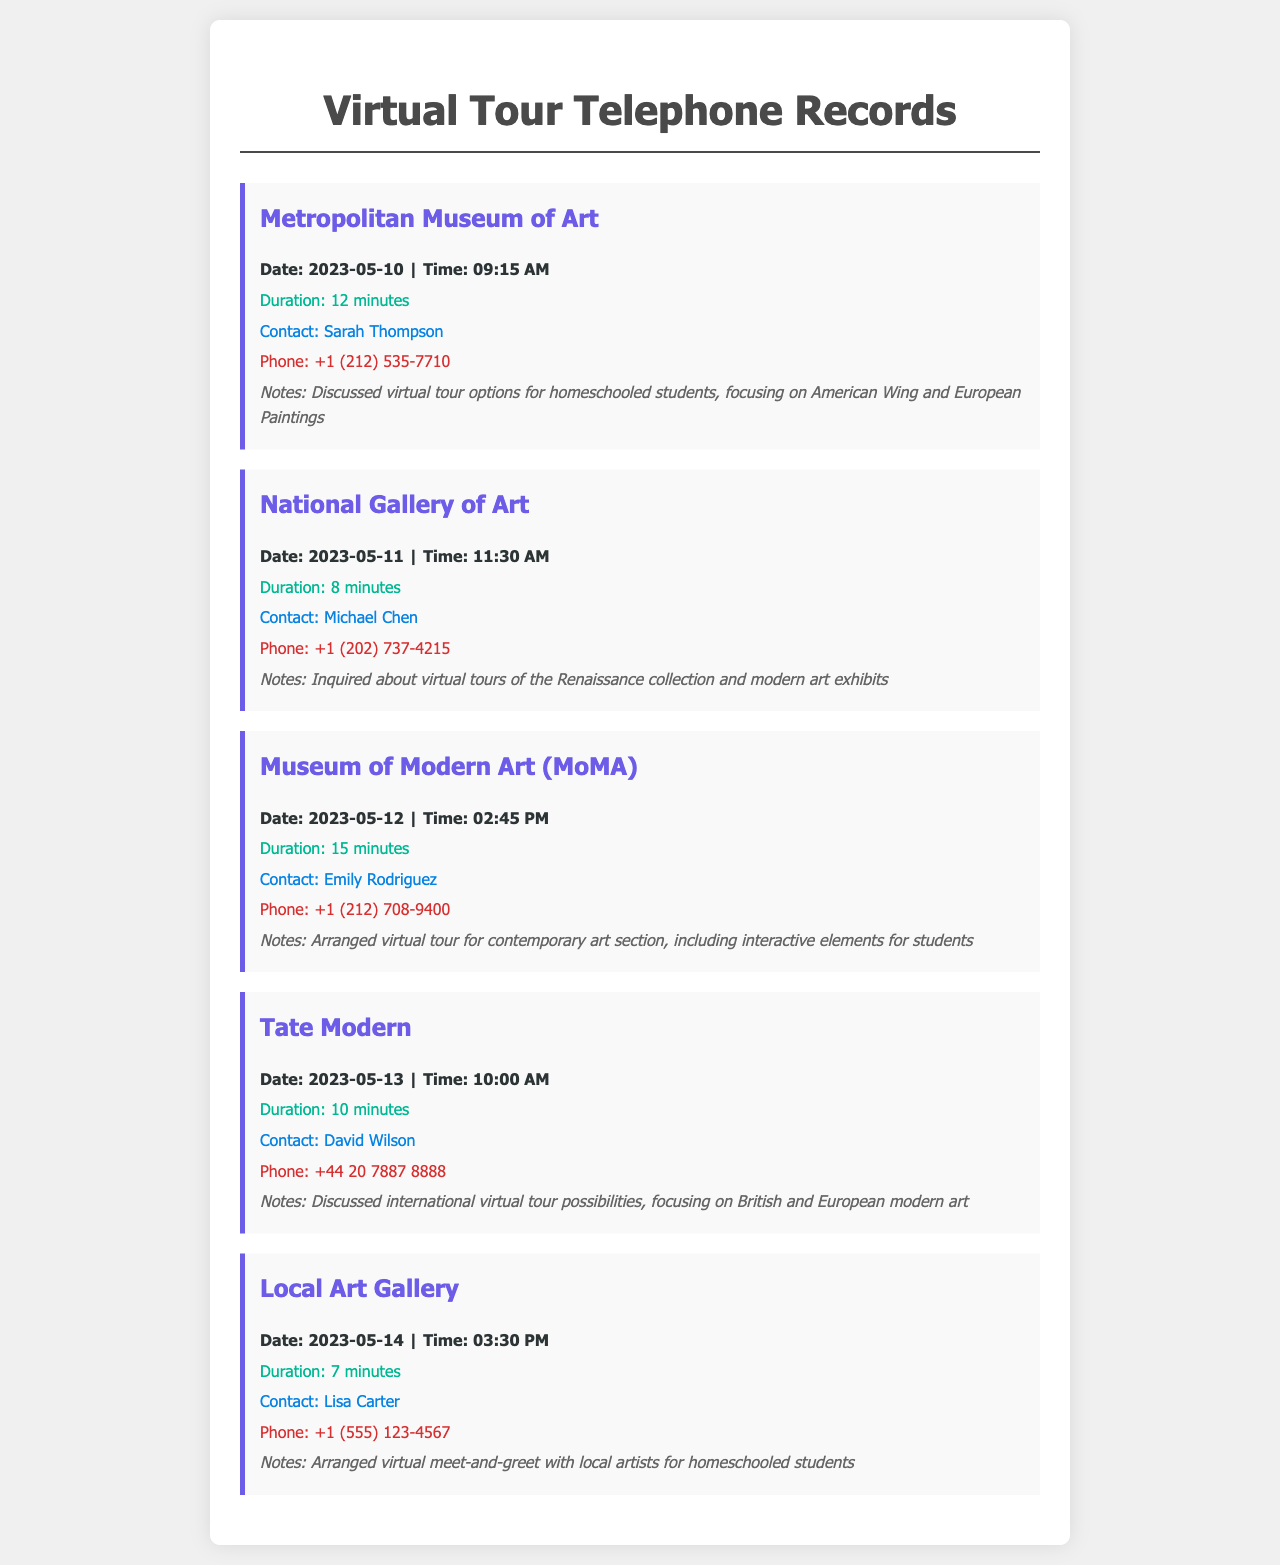what is the first museum contacted? The first call in the document is recorded under the Metropolitan Museum of Art, which can be determined by the order of the records displayed.
Answer: Metropolitan Museum of Art who was the contact person for the National Gallery of Art? From the record for the National Gallery of Art, the person contacted is listed as Michael Chen.
Answer: Michael Chen what was the duration of the call to the Museum of Modern Art? The duration of the call to the Museum of Modern Art (MoMA) is indicated within the details of that record as 15 minutes.
Answer: 15 minutes how many calls were made to local art institutions on May 12th? The only call made on May 12th, as referenced in the document, was to the Museum of Modern Art.
Answer: 1 which gallery discussed international virtual tour possibilities? The document specifies that Tate Modern discussed international virtual tour possibilities based on the description of that call record.
Answer: Tate Modern who is the contact for the virtual meet-and-greet with local artists? The Local Art Gallery record indicates that the contact person for the virtual meet-and-greet is Lisa Carter.
Answer: Lisa Carter what collection was inquired about during the call to the National Gallery of Art? The notes in the record for the National Gallery of Art mention an inquiry about the Renaissance collection and modern art exhibits.
Answer: Renaissance collection and modern art exhibits 